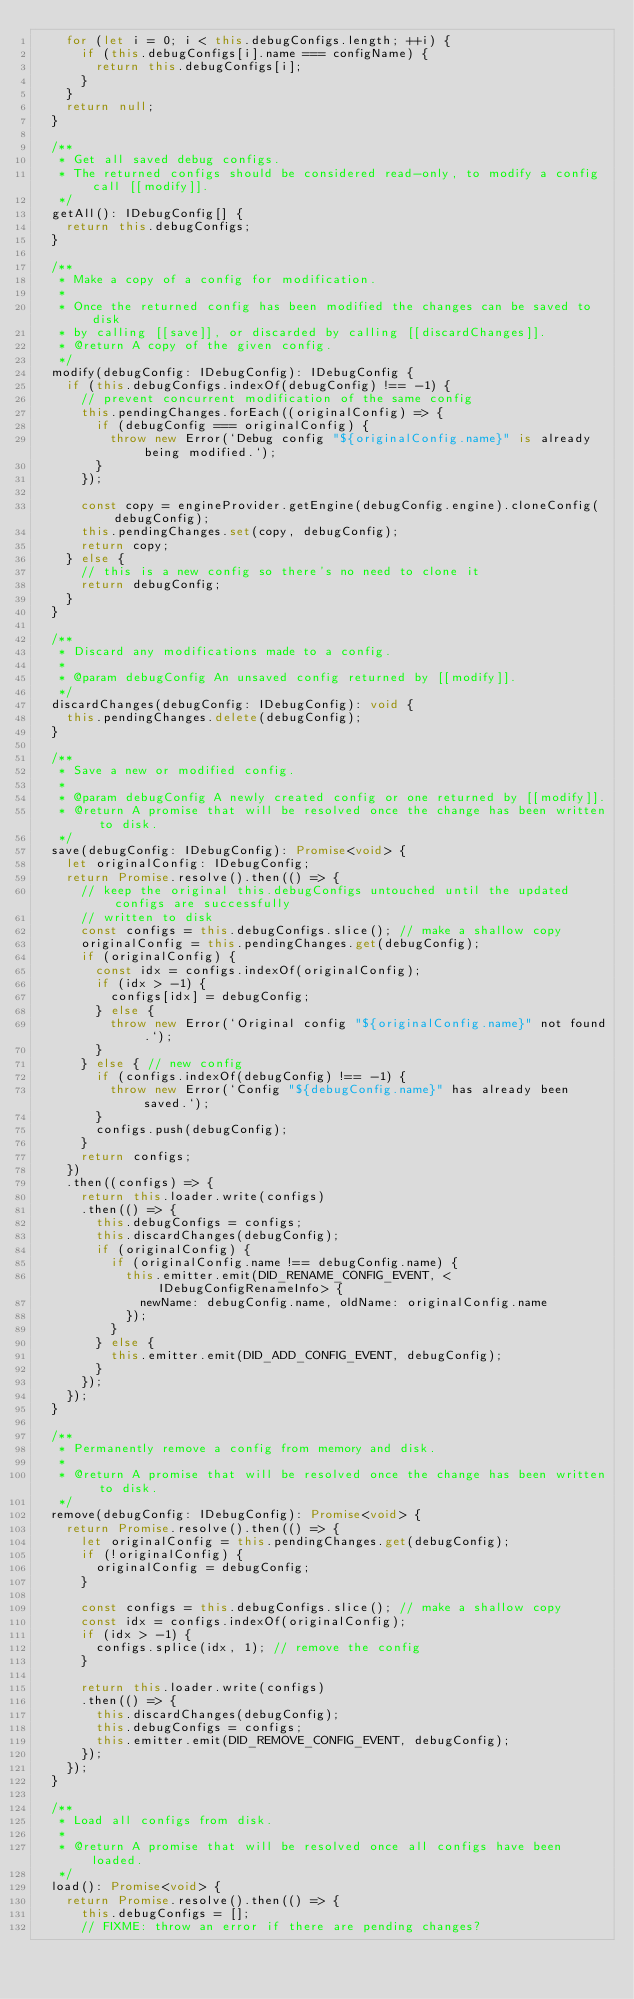<code> <loc_0><loc_0><loc_500><loc_500><_TypeScript_>    for (let i = 0; i < this.debugConfigs.length; ++i) {
      if (this.debugConfigs[i].name === configName) {
        return this.debugConfigs[i];
      }
    }
    return null;
  }

  /**
   * Get all saved debug configs.
   * The returned configs should be considered read-only, to modify a config call [[modify]].
   */
  getAll(): IDebugConfig[] {
    return this.debugConfigs;
  }

  /**
   * Make a copy of a config for modification.
   *
   * Once the returned config has been modified the changes can be saved to disk
   * by calling [[save]], or discarded by calling [[discardChanges]].
   * @return A copy of the given config.
   */
  modify(debugConfig: IDebugConfig): IDebugConfig {
    if (this.debugConfigs.indexOf(debugConfig) !== -1) {
      // prevent concurrent modification of the same config
      this.pendingChanges.forEach((originalConfig) => {
        if (debugConfig === originalConfig) {
          throw new Error(`Debug config "${originalConfig.name}" is already being modified.`);
        }
      });

      const copy = engineProvider.getEngine(debugConfig.engine).cloneConfig(debugConfig);
      this.pendingChanges.set(copy, debugConfig);
      return copy;
    } else {
      // this is a new config so there's no need to clone it
      return debugConfig;
    }
  }

  /**
   * Discard any modifications made to a config.
   *
   * @param debugConfig An unsaved config returned by [[modify]].
   */
  discardChanges(debugConfig: IDebugConfig): void {
    this.pendingChanges.delete(debugConfig);
  }

  /**
   * Save a new or modified config.
   *
   * @param debugConfig A newly created config or one returned by [[modify]].
   * @return A promise that will be resolved once the change has been written to disk.
   */
  save(debugConfig: IDebugConfig): Promise<void> {
    let originalConfig: IDebugConfig;
    return Promise.resolve().then(() => {
      // keep the original this.debugConfigs untouched until the updated configs are successfully
      // written to disk
      const configs = this.debugConfigs.slice(); // make a shallow copy
      originalConfig = this.pendingChanges.get(debugConfig);
      if (originalConfig) {
        const idx = configs.indexOf(originalConfig);
        if (idx > -1) {
          configs[idx] = debugConfig;
        } else {
          throw new Error(`Original config "${originalConfig.name}" not found.`);
        }
      } else { // new config
        if (configs.indexOf(debugConfig) !== -1) {
          throw new Error(`Config "${debugConfig.name}" has already been saved.`);
        }
        configs.push(debugConfig);
      }
      return configs;
    })
    .then((configs) => {
      return this.loader.write(configs)
      .then(() => {
        this.debugConfigs = configs;
        this.discardChanges(debugConfig);
        if (originalConfig) {
          if (originalConfig.name !== debugConfig.name) {
            this.emitter.emit(DID_RENAME_CONFIG_EVENT, <IDebugConfigRenameInfo> {
              newName: debugConfig.name, oldName: originalConfig.name
            });
          }
        } else {
          this.emitter.emit(DID_ADD_CONFIG_EVENT, debugConfig);
        }
      });
    });
  }

  /**
   * Permanently remove a config from memory and disk.
   *
   * @return A promise that will be resolved once the change has been written to disk.
   */
  remove(debugConfig: IDebugConfig): Promise<void> {
    return Promise.resolve().then(() => {
      let originalConfig = this.pendingChanges.get(debugConfig);
      if (!originalConfig) {
        originalConfig = debugConfig;
      }

      const configs = this.debugConfigs.slice(); // make a shallow copy
      const idx = configs.indexOf(originalConfig);
      if (idx > -1) {
        configs.splice(idx, 1); // remove the config
      }

      return this.loader.write(configs)
      .then(() => {
        this.discardChanges(debugConfig);
        this.debugConfigs = configs;
        this.emitter.emit(DID_REMOVE_CONFIG_EVENT, debugConfig);
      });
    });
  }

  /**
   * Load all configs from disk.
   *
   * @return A promise that will be resolved once all configs have been loaded.
   */
  load(): Promise<void> {
    return Promise.resolve().then(() => {
      this.debugConfigs = [];
      // FIXME: throw an error if there are pending changes?</code> 